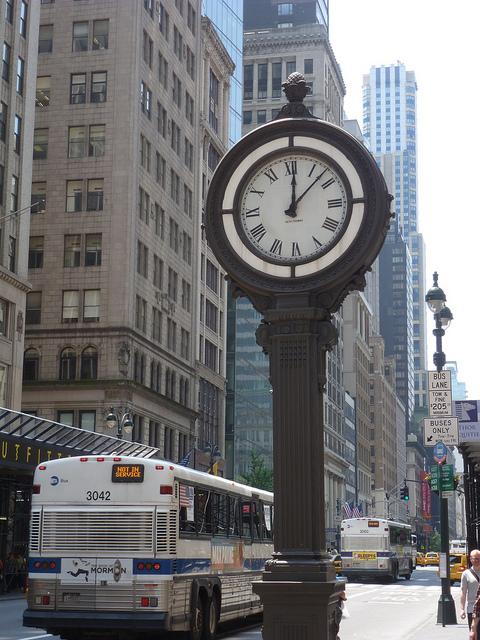What time is it?
Write a very short answer. 12:07. Is early in the morning?
Write a very short answer. No. Is the building green and red?
Concise answer only. No. Where are the people?
Be succinct. Sidewalk. 